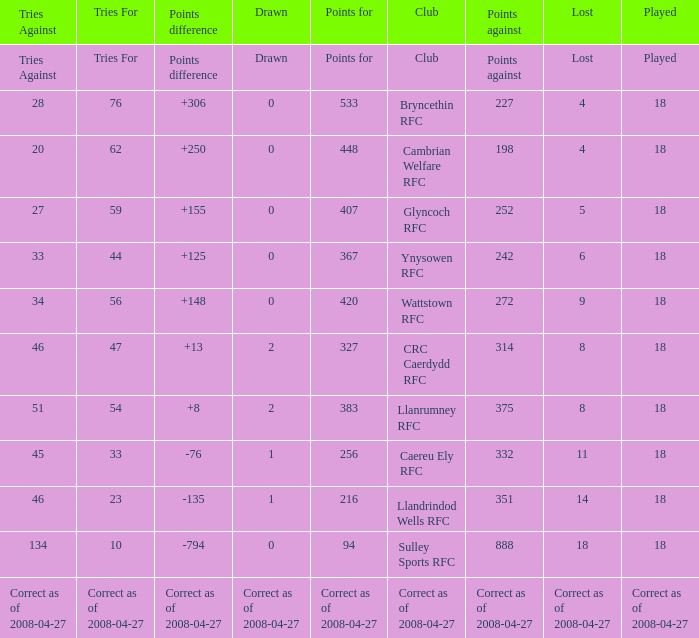What is the value of the item "Points" when the value of the item "Points against" is 272? 420.0. 